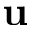<formula> <loc_0><loc_0><loc_500><loc_500>u</formula> 